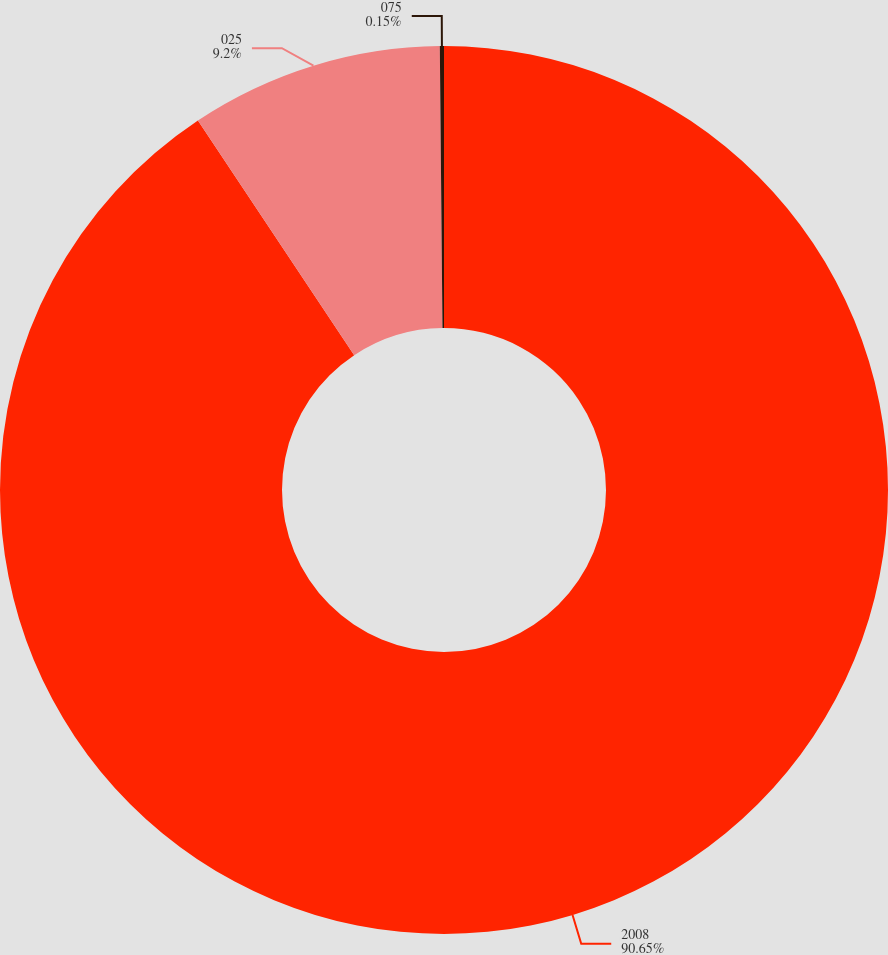<chart> <loc_0><loc_0><loc_500><loc_500><pie_chart><fcel>2008<fcel>025<fcel>075<nl><fcel>90.65%<fcel>9.2%<fcel>0.15%<nl></chart> 